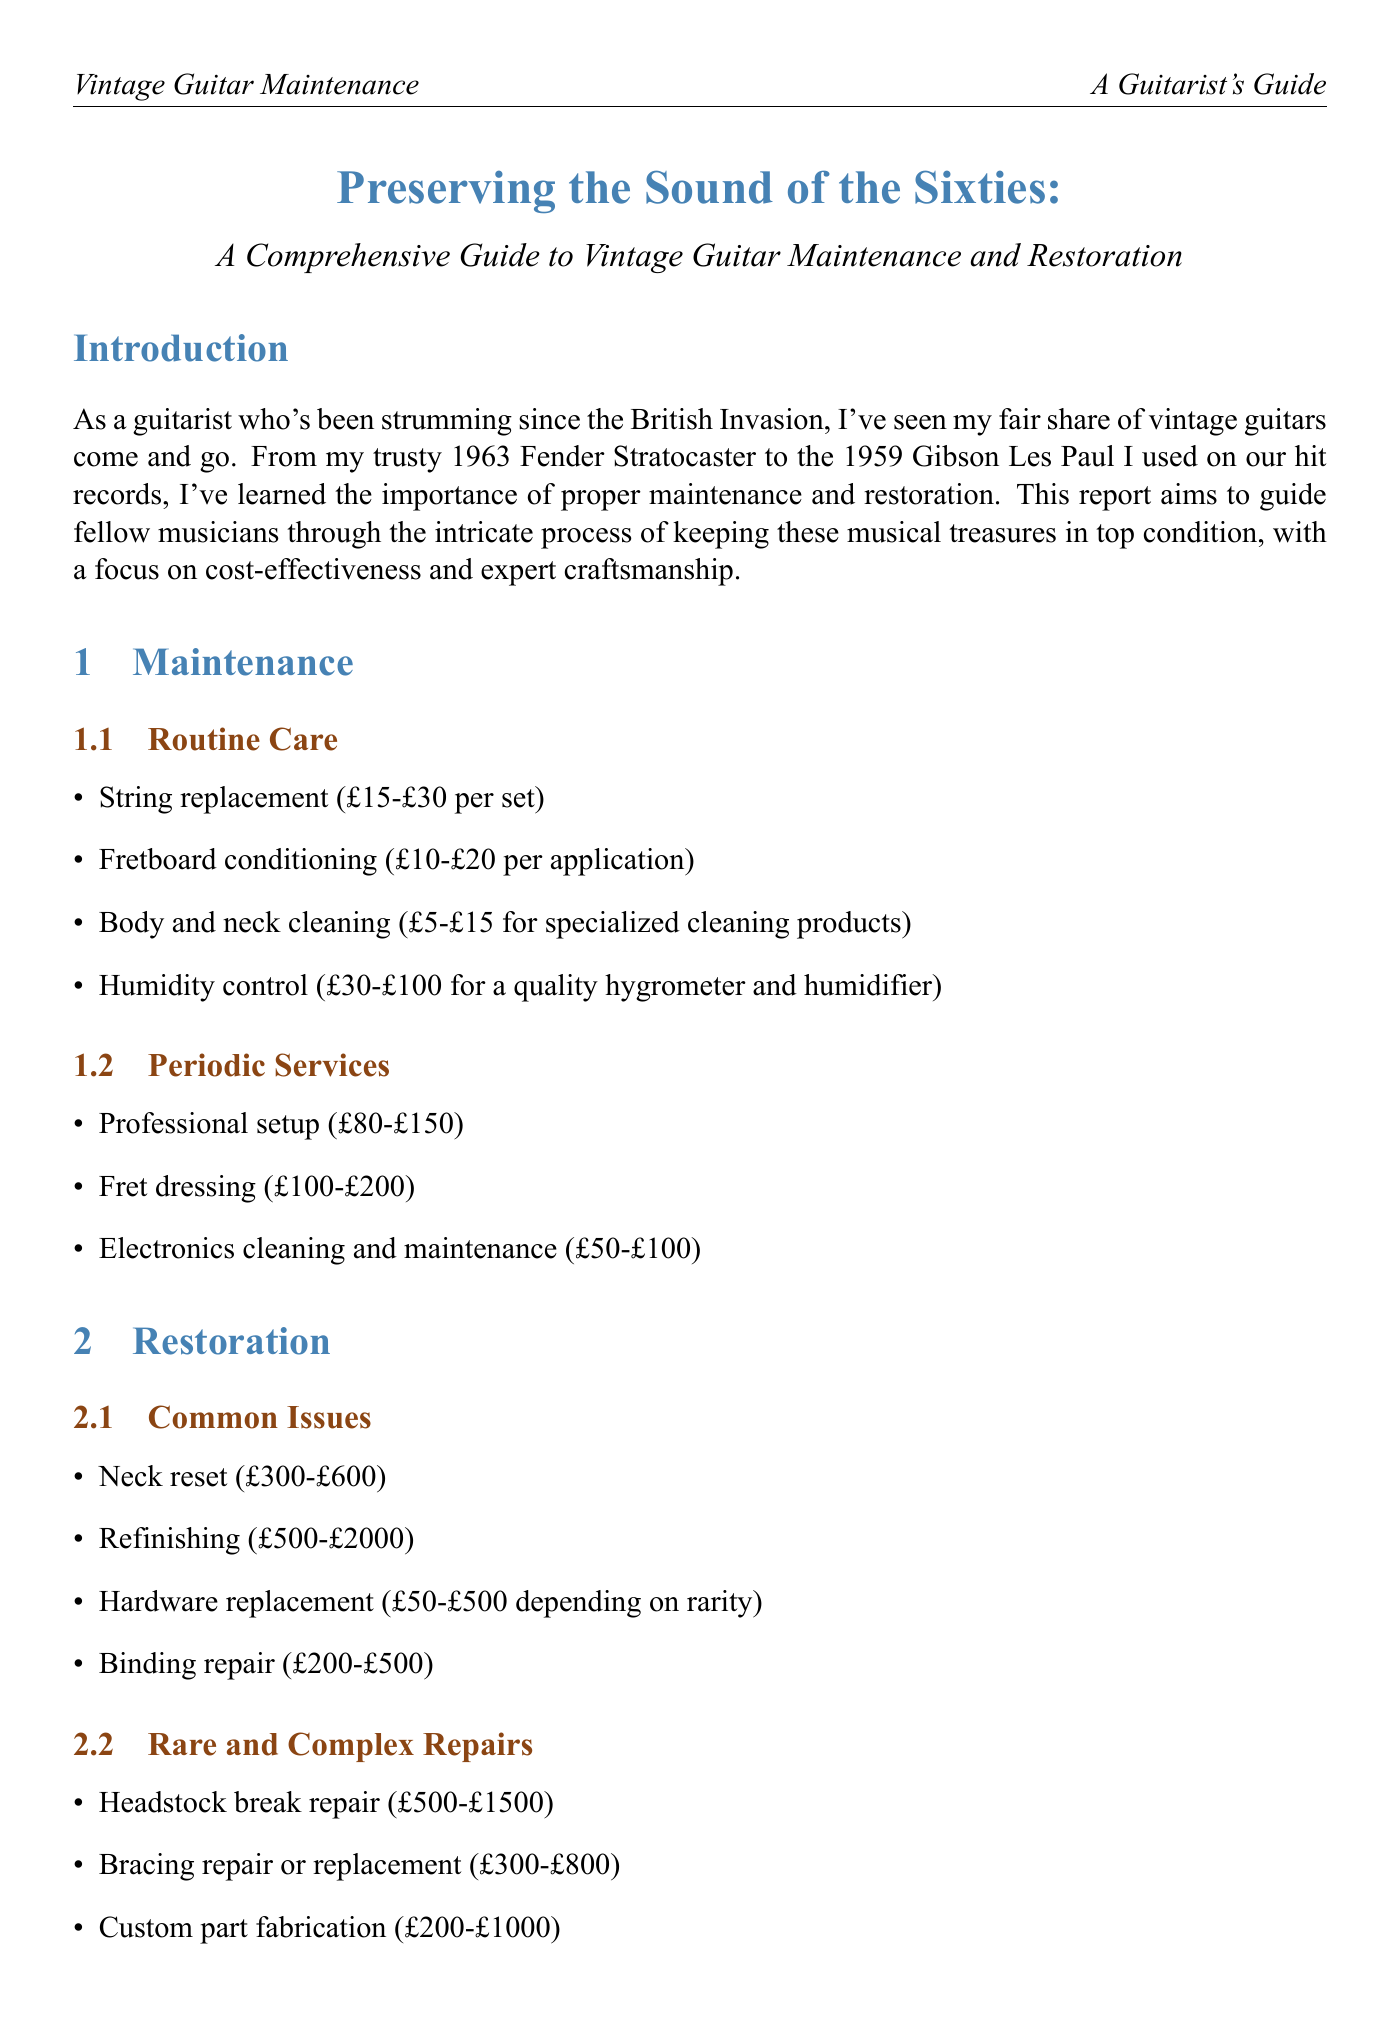What is the title of the report? The title of the report is explicitly provided at the beginning, which is "Preserving the Sound of the Sixties: A Comprehensive Guide to Vintage Guitar Maintenance and Restoration."
Answer: Preserving the Sound of the Sixties: A Comprehensive Guide to Vintage Guitar Maintenance and Restoration What is the location of Andy's Guitar Workshop? The report lists the location of Andy's Guitar Workshop in the recommended specialists section.
Answer: London What is the cost range for a neck reset? The report specifies the cost range for a neck reset under common issues in the restoration section.
Answer: £300-£600 Which service has a cost range of £100-£200? The periodic services in the maintenance section outline multiple services, one of which falls into this cost range.
Answer: Fret dressing What should you do when faced with structural issues? The DIY tips section advises on getting professional help for specific issues, highlighting the importance of expert care.
Answer: Consult a professional What factor affecting cost is mentioned related to original parts? One of the factors affecting the cost of maintenance and restoration is outlined, specifically regarding the availability of specific components.
Answer: Availability of original parts Which city is home to Vintage Axe Clinic? The report includes a table of recommended specialists, which lists the city for each.
Answer: Liverpool What type of guitar repairs does Charlie's String Theory specialize in? The expertise of Charlie's String Theory is detailed in the recommended specialists section, focusing on specific modifications.
Answer: Electronics and custom modifications What is the investment perspective regarding restoration? The report provides insight into the financial implications of restoring vintage instruments, emphasizing the potential increase in value.
Answer: Increases the value of vintage instruments 